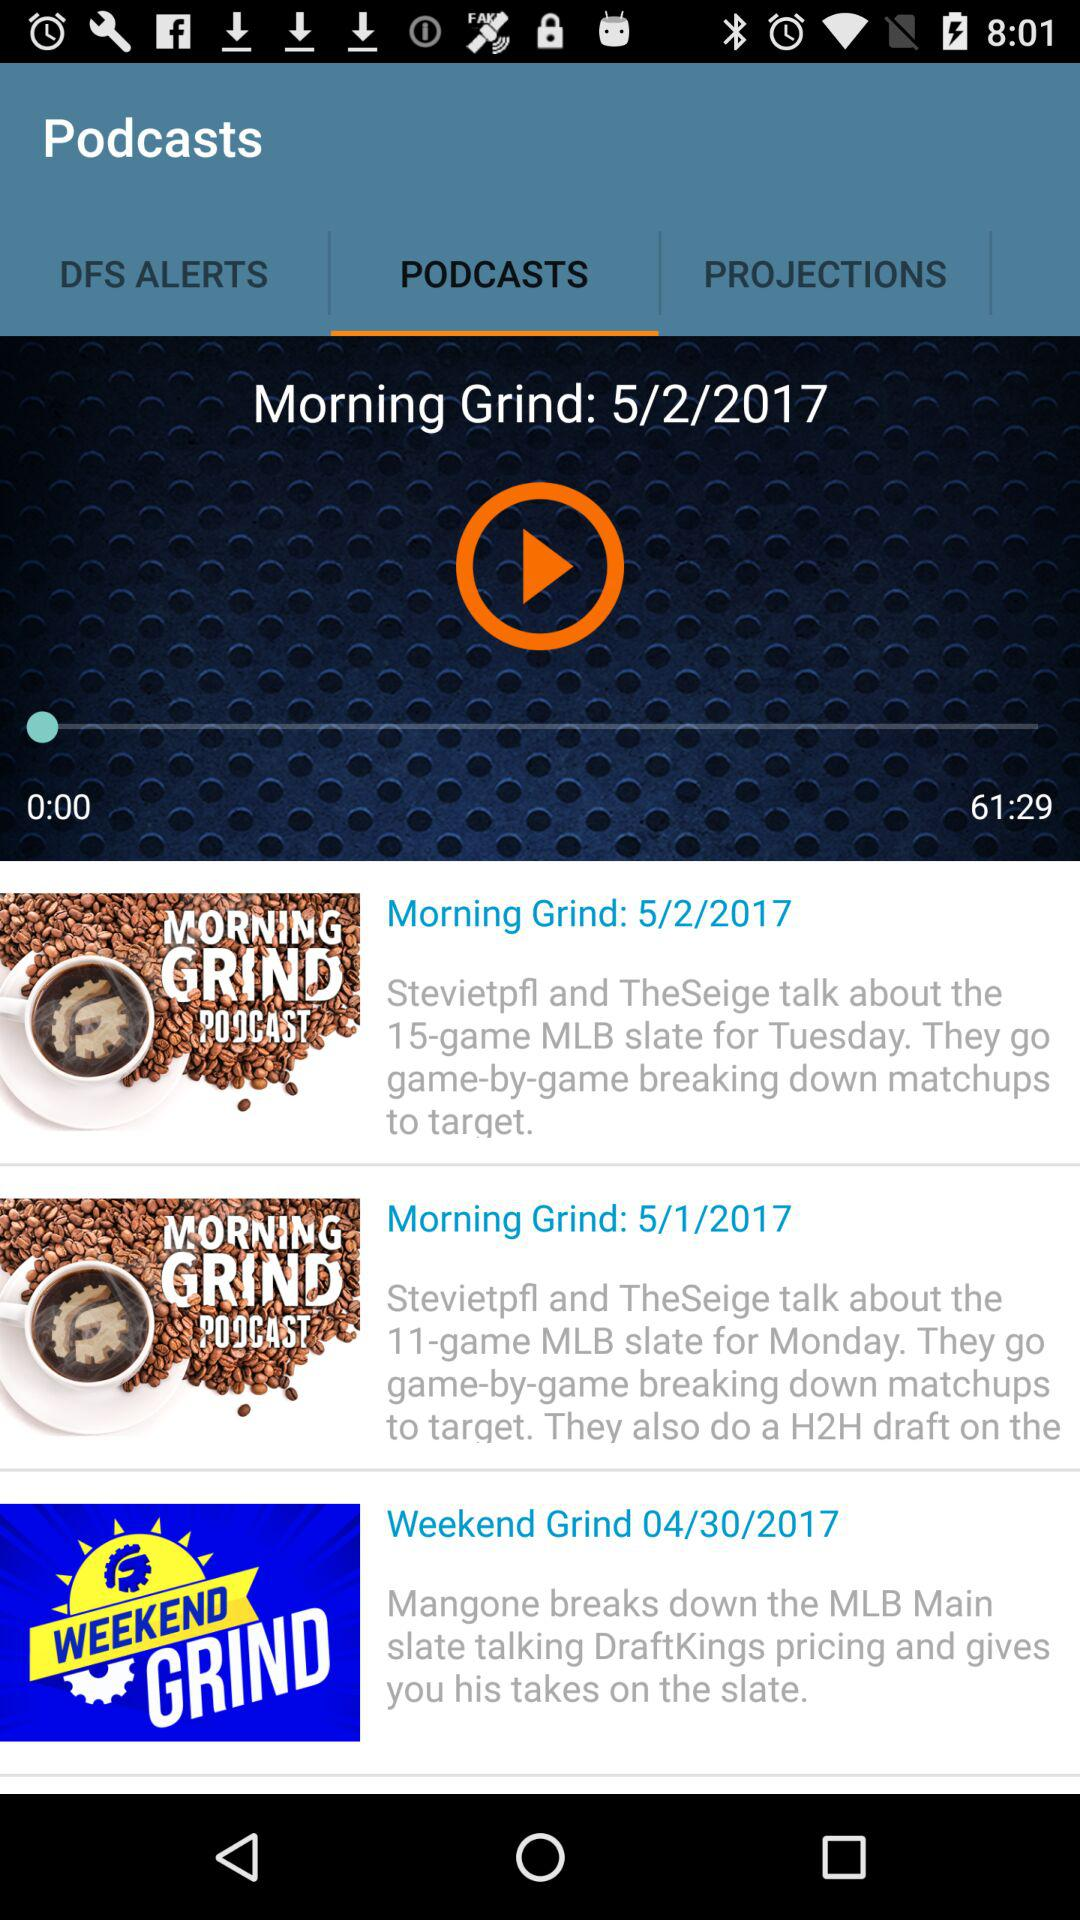What is the duration of the video? The duration of the video is 61 minutes and 29 seconds. 